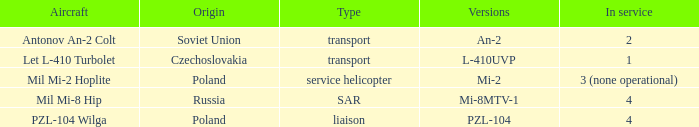Explain the service for models l-410uvp 1.0. 